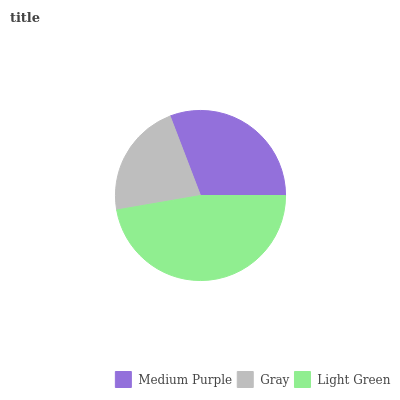Is Gray the minimum?
Answer yes or no. Yes. Is Light Green the maximum?
Answer yes or no. Yes. Is Light Green the minimum?
Answer yes or no. No. Is Gray the maximum?
Answer yes or no. No. Is Light Green greater than Gray?
Answer yes or no. Yes. Is Gray less than Light Green?
Answer yes or no. Yes. Is Gray greater than Light Green?
Answer yes or no. No. Is Light Green less than Gray?
Answer yes or no. No. Is Medium Purple the high median?
Answer yes or no. Yes. Is Medium Purple the low median?
Answer yes or no. Yes. Is Light Green the high median?
Answer yes or no. No. Is Gray the low median?
Answer yes or no. No. 